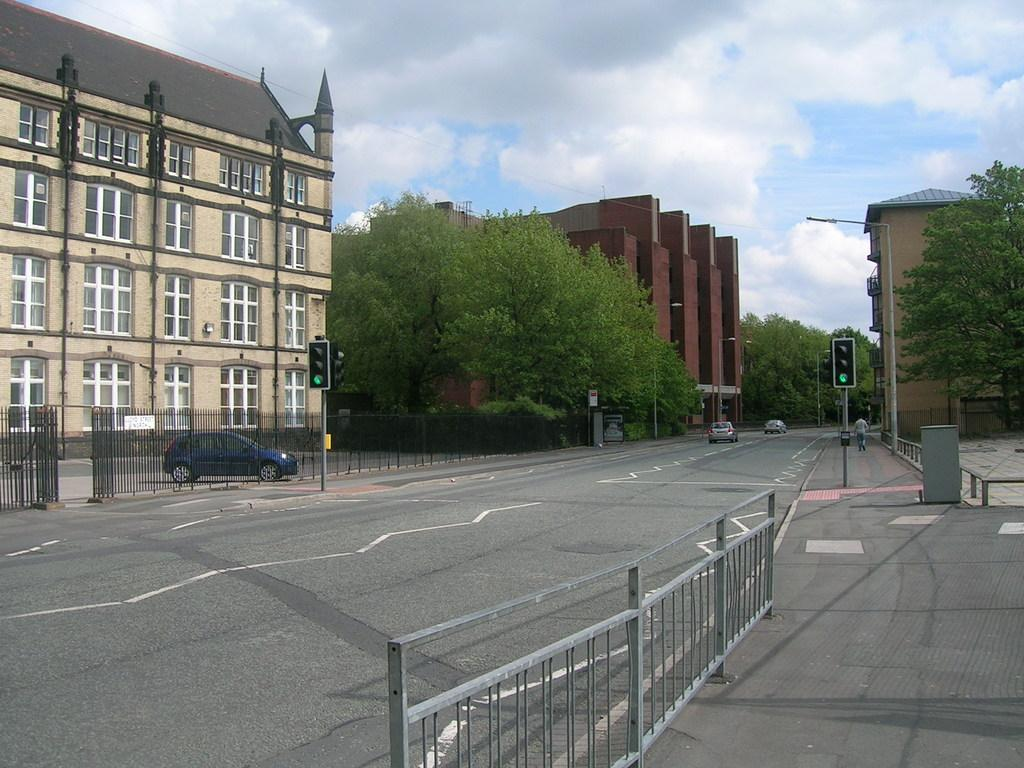What can be seen on the left side of the image? There is a car parked on the road on the left side of the image. What type of structure is visible in the image? There is a building in the image. What is located in the middle of the image? There are trees in the middle of the image. What can be seen on the right side of the image? There are traffic signals on the right side of the image. Can you tell me what type of attraction is near the trees in the image? There is no attraction mentioned or visible in the image; it only features a car, a building, trees, and traffic signals. Is there a judge present in the image? No, there is no judge present in the image. 